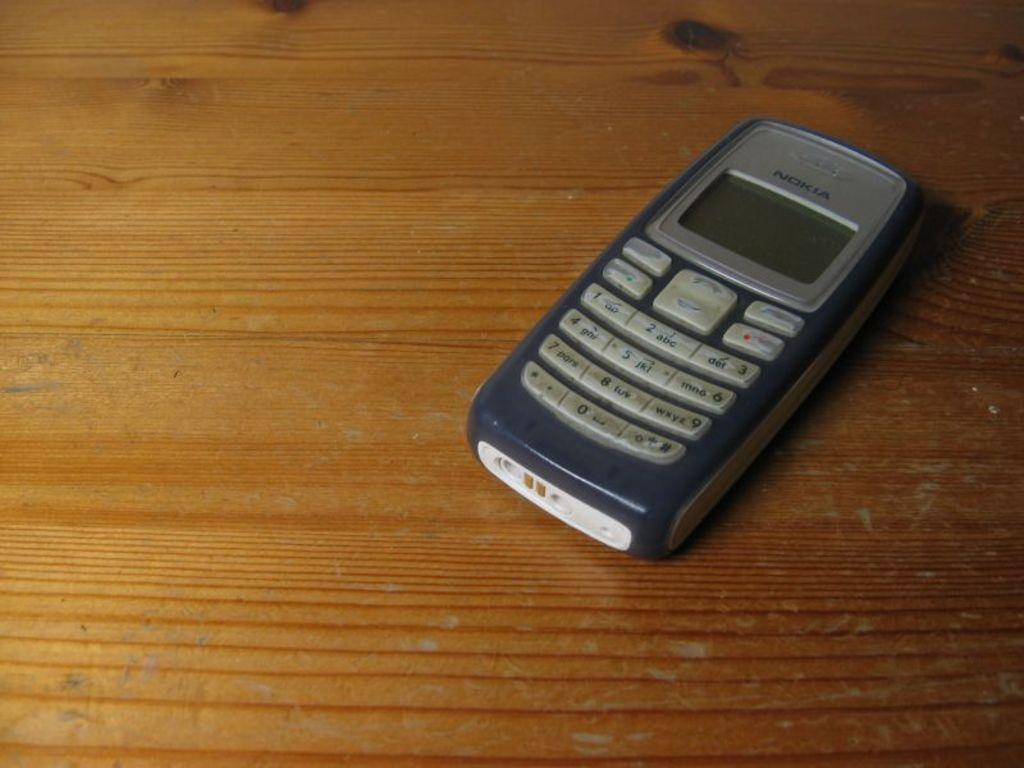Provide a one-sentence caption for the provided image. An older grey Nokia cell phone laying on a table. 